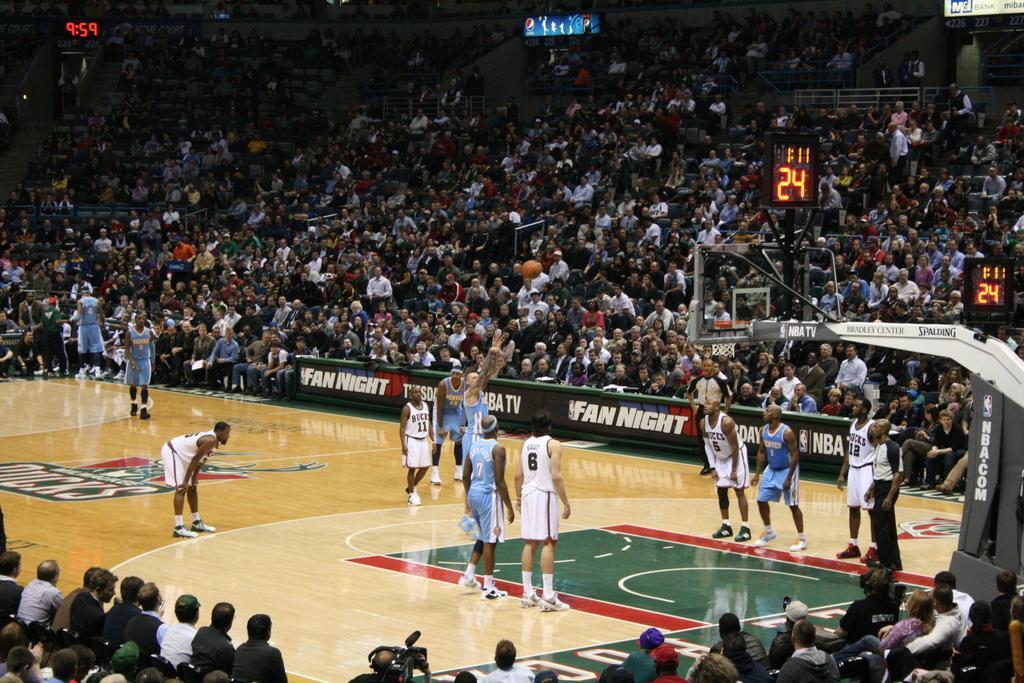Describe this image in one or two sentences. in the center of the image we can see a group of people standing on the floor. In the foreground we can see a person holding camera and a group of people sitting. On the right side of the image we can see a goal post, two scoreboards. In the background, we can see some audience and a board with some text on it. 